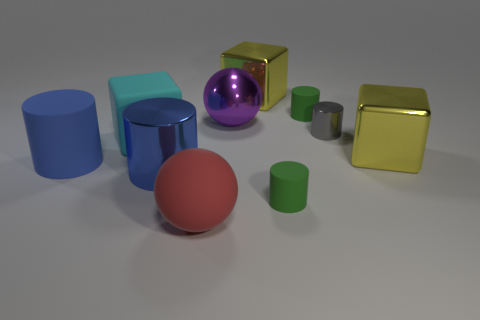Subtract all large cyan matte cubes. How many cubes are left? 2 Subtract all spheres. How many objects are left? 8 Subtract 1 cylinders. How many cylinders are left? 4 Subtract all brown spheres. Subtract all green cubes. How many spheres are left? 2 Subtract all green spheres. How many yellow blocks are left? 2 Subtract all red matte blocks. Subtract all blue metallic cylinders. How many objects are left? 9 Add 2 rubber cylinders. How many rubber cylinders are left? 5 Add 8 red matte spheres. How many red matte spheres exist? 9 Subtract all red balls. How many balls are left? 1 Subtract 0 red cylinders. How many objects are left? 10 